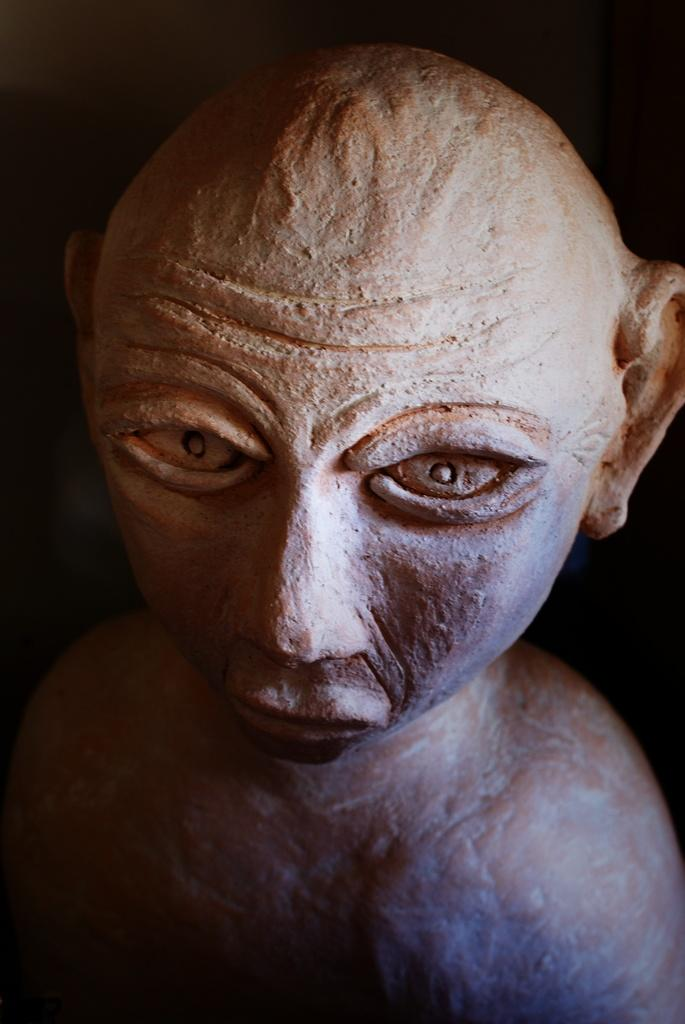What is the main subject in the image? There is a statue of a man in the image. What can be observed about the background of the image? The background of the image is dark. What type of hope can be seen growing in the field in the image? There is no field or hope present in the image; it features a statue of a man with a dark background. What type of polish is being used to maintain the statue in the image? There is no indication of any polish or maintenance activity in the image. 